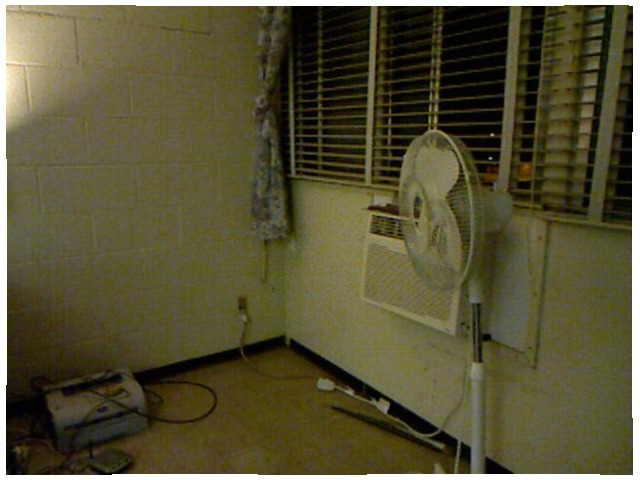<image>
Is the fan to the left of the air conditioner? No. The fan is not to the left of the air conditioner. From this viewpoint, they have a different horizontal relationship. Is there a window next to the fan? Yes. The window is positioned adjacent to the fan, located nearby in the same general area. Is there a air conditioner behind the fan? Yes. From this viewpoint, the air conditioner is positioned behind the fan, with the fan partially or fully occluding the air conditioner. Is there a windows behind the fan? Yes. From this viewpoint, the windows is positioned behind the fan, with the fan partially or fully occluding the windows. 